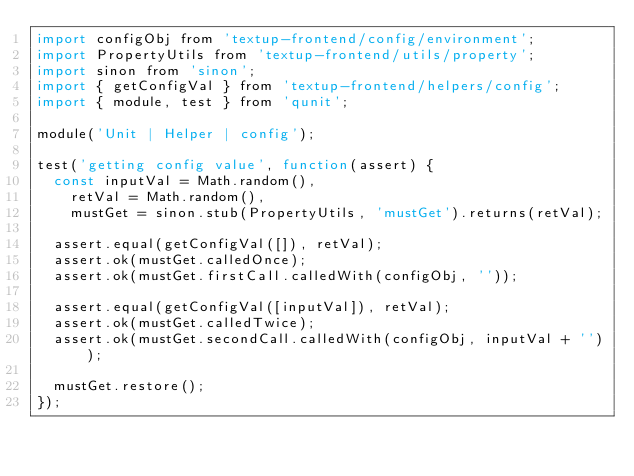Convert code to text. <code><loc_0><loc_0><loc_500><loc_500><_JavaScript_>import configObj from 'textup-frontend/config/environment';
import PropertyUtils from 'textup-frontend/utils/property';
import sinon from 'sinon';
import { getConfigVal } from 'textup-frontend/helpers/config';
import { module, test } from 'qunit';

module('Unit | Helper | config');

test('getting config value', function(assert) {
  const inputVal = Math.random(),
    retVal = Math.random(),
    mustGet = sinon.stub(PropertyUtils, 'mustGet').returns(retVal);

  assert.equal(getConfigVal([]), retVal);
  assert.ok(mustGet.calledOnce);
  assert.ok(mustGet.firstCall.calledWith(configObj, ''));

  assert.equal(getConfigVal([inputVal]), retVal);
  assert.ok(mustGet.calledTwice);
  assert.ok(mustGet.secondCall.calledWith(configObj, inputVal + ''));

  mustGet.restore();
});
</code> 